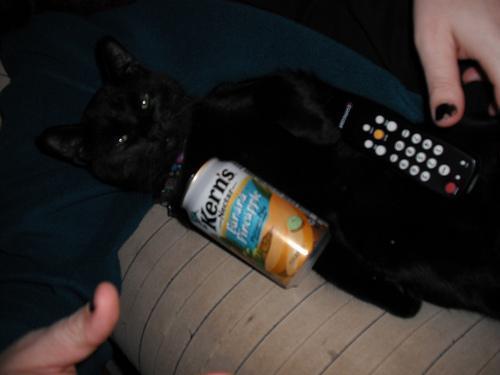The remote control placed on top of the black cat controls what object?
Pick the correct solution from the four options below to address the question.
Options: Cable box, vcr, dvd player, television. Cable box. 